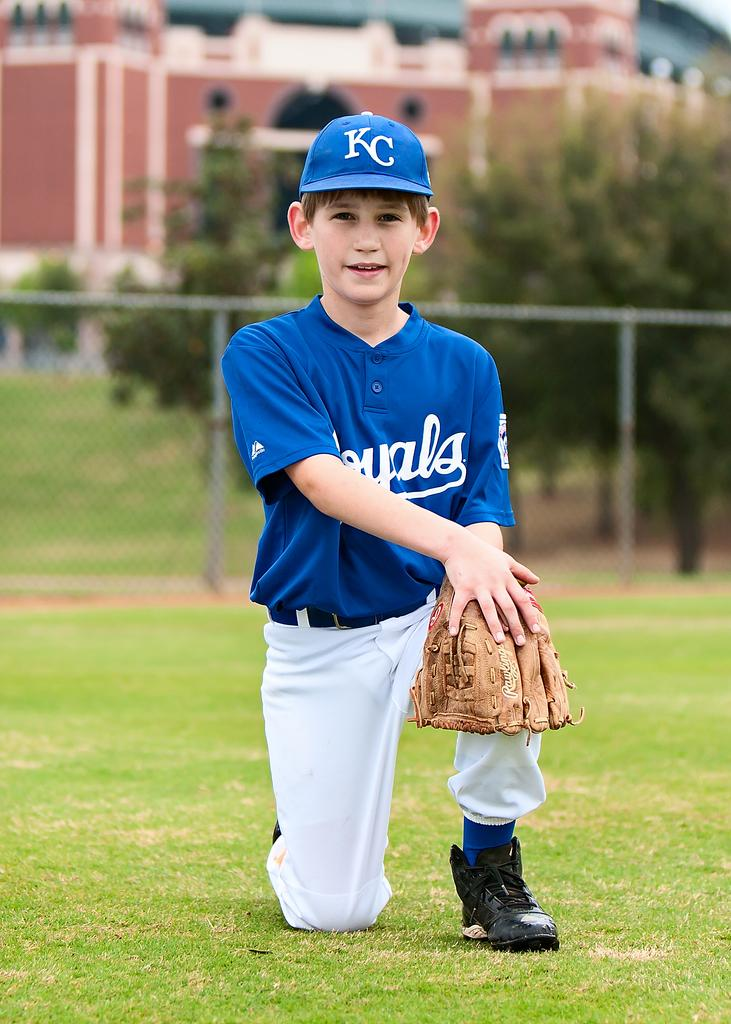<image>
Give a short and clear explanation of the subsequent image. a person with the word Royals on the front of the shirt 